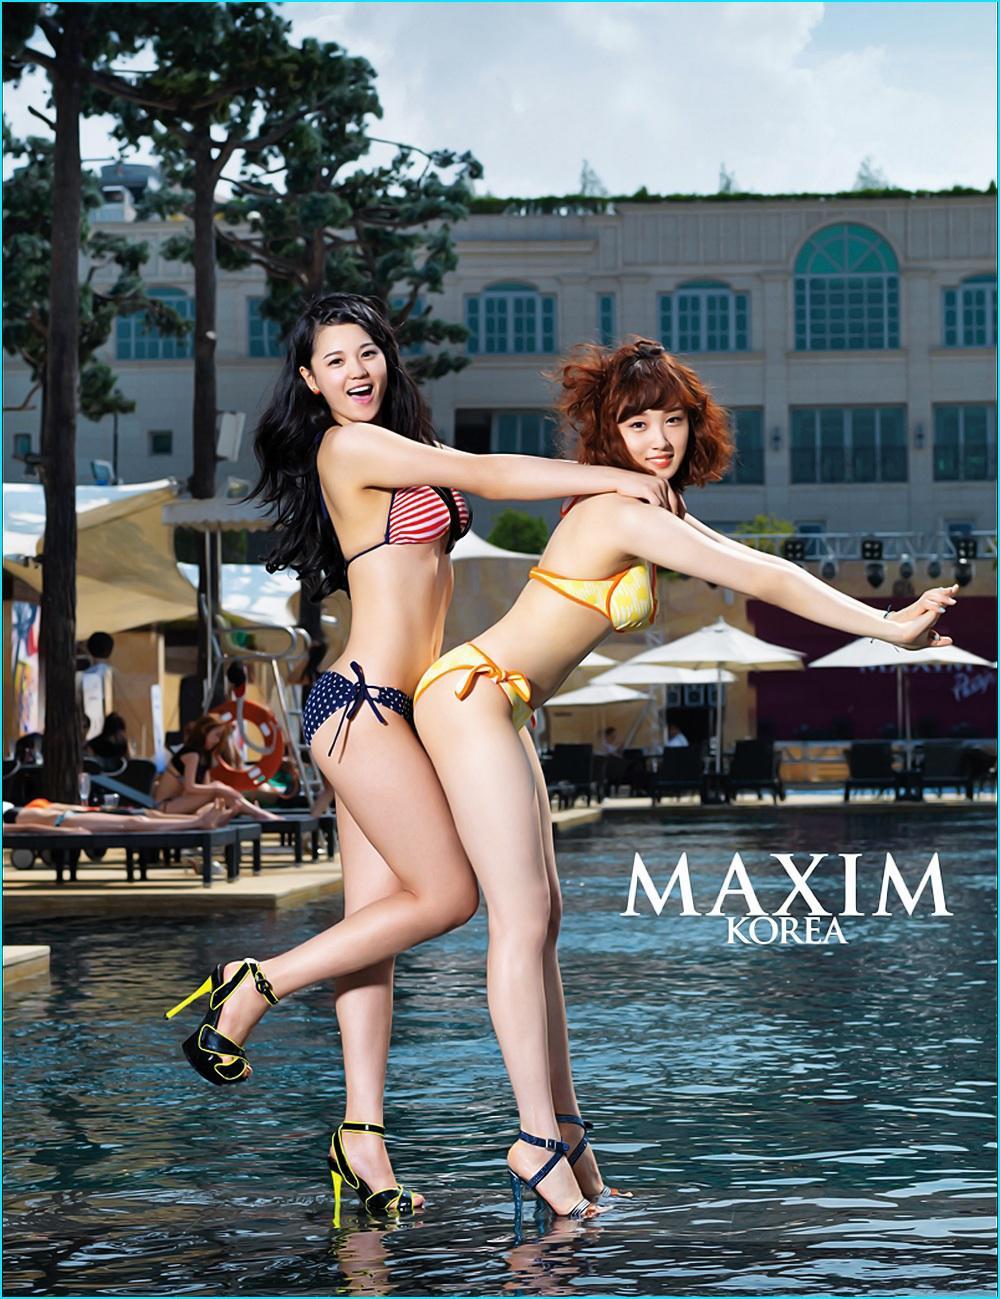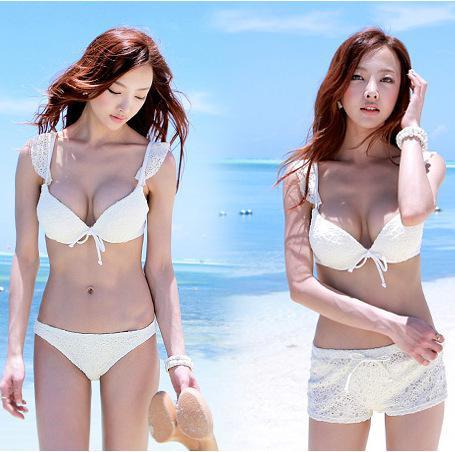The first image is the image on the left, the second image is the image on the right. For the images shown, is this caption "The left and right image contains the same number of women in bikinis." true? Answer yes or no. Yes. 